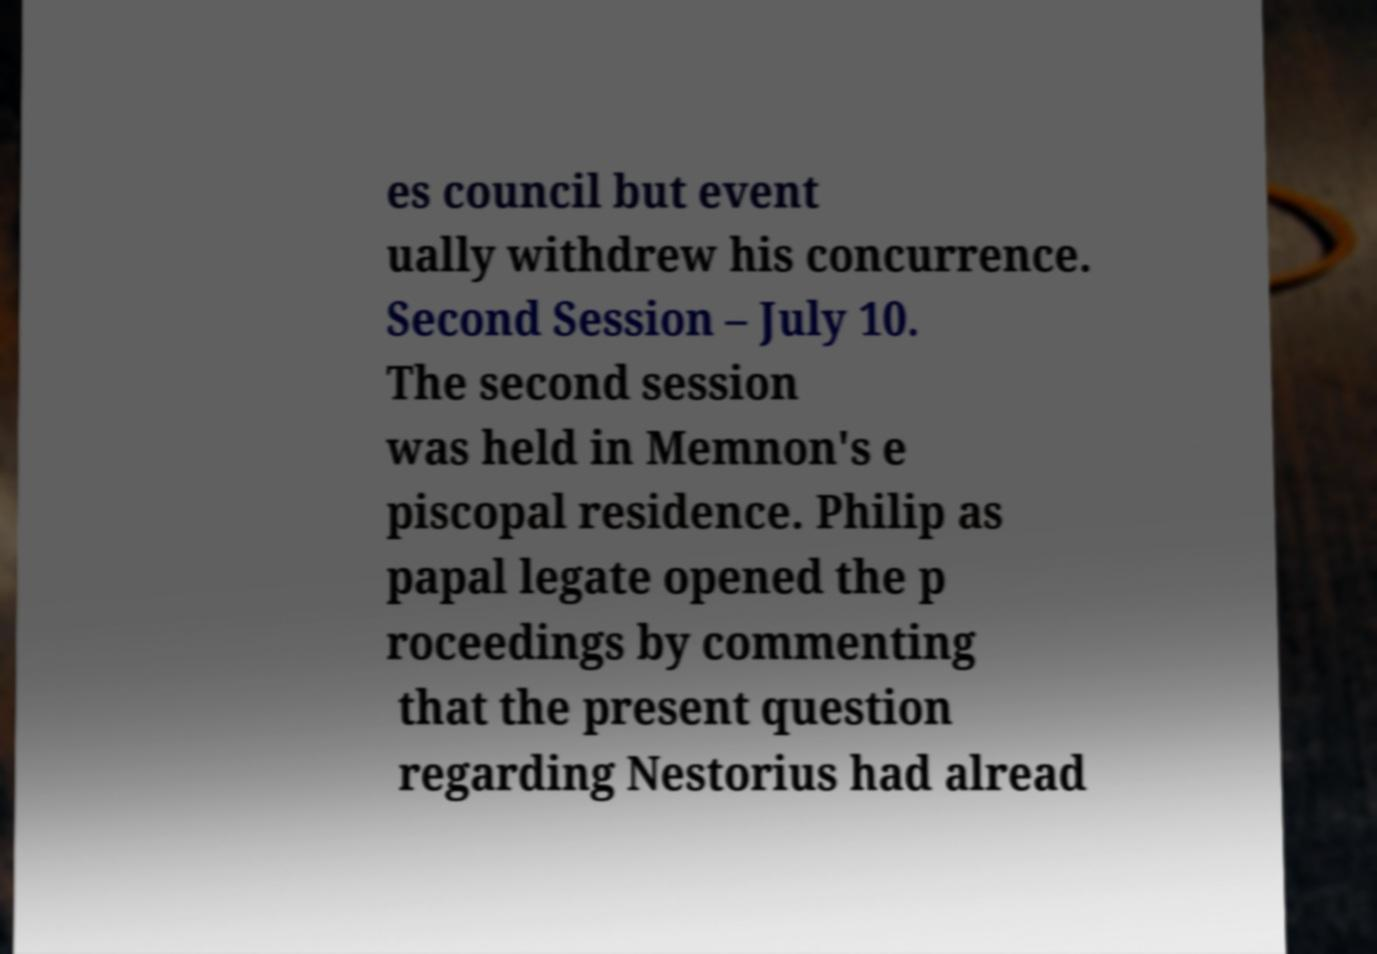Please identify and transcribe the text found in this image. es council but event ually withdrew his concurrence. Second Session – July 10. The second session was held in Memnon's e piscopal residence. Philip as papal legate opened the p roceedings by commenting that the present question regarding Nestorius had alread 